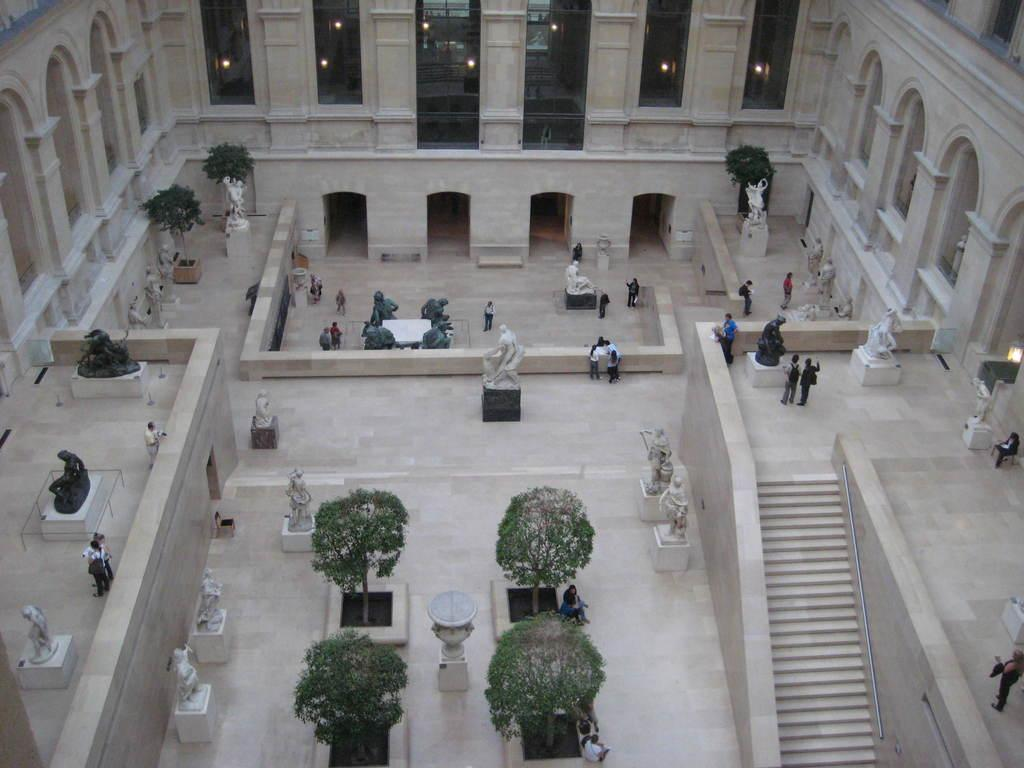What type of structures can be seen in the image? There are statues, trees, steps, windows, and lights visible in the image. What is the setting of the image? The image features a group of people, some of whom are standing on the floor and some of whom are sitting. What can be seen in the background of the image? There are trees and statues in the background of the image. What objects are present in the image? There are objects in the image, but their specific nature is not mentioned in the provided facts. What type of roof can be seen in the image? There is no roof present in the image; the focus is on the statues, trees, steps, windows, lights, and the group of people. 